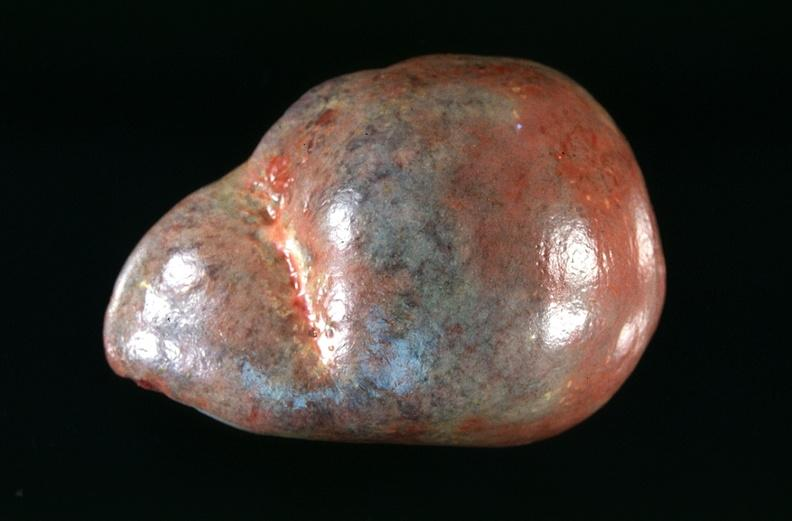s hematologic present?
Answer the question using a single word or phrase. Yes 